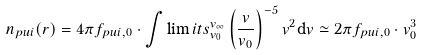<formula> <loc_0><loc_0><loc_500><loc_500>n _ { p u i } ( r ) = 4 \pi f _ { p u i , 0 } \cdot \int \lim i t s _ { v _ { 0 } } ^ { v _ { \infty } } \left ( \frac { v } { v _ { 0 } } \right ) ^ { - 5 } v ^ { 2 } \mathrm d v \simeq 2 \pi f _ { p u i , 0 } \cdot v _ { 0 } ^ { 3 }</formula> 